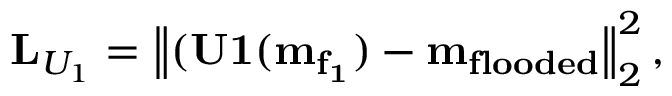Convert formula to latex. <formula><loc_0><loc_0><loc_500><loc_500>L _ { U _ { 1 } } = \left \| ( U 1 ( m _ { f _ { 1 } } ) - m _ { f l o o d e d } \right \| _ { 2 } ^ { 2 } ,</formula> 